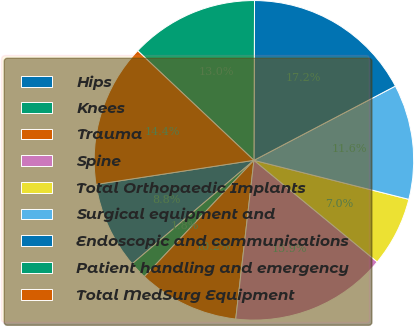<chart> <loc_0><loc_0><loc_500><loc_500><pie_chart><fcel>Hips<fcel>Knees<fcel>Trauma<fcel>Spine<fcel>Total Orthopaedic Implants<fcel>Surgical equipment and<fcel>Endoscopic and communications<fcel>Patient handling and emergency<fcel>Total MedSurg Equipment<nl><fcel>8.8%<fcel>1.76%<fcel>10.21%<fcel>15.85%<fcel>7.04%<fcel>11.62%<fcel>17.25%<fcel>13.03%<fcel>14.44%<nl></chart> 